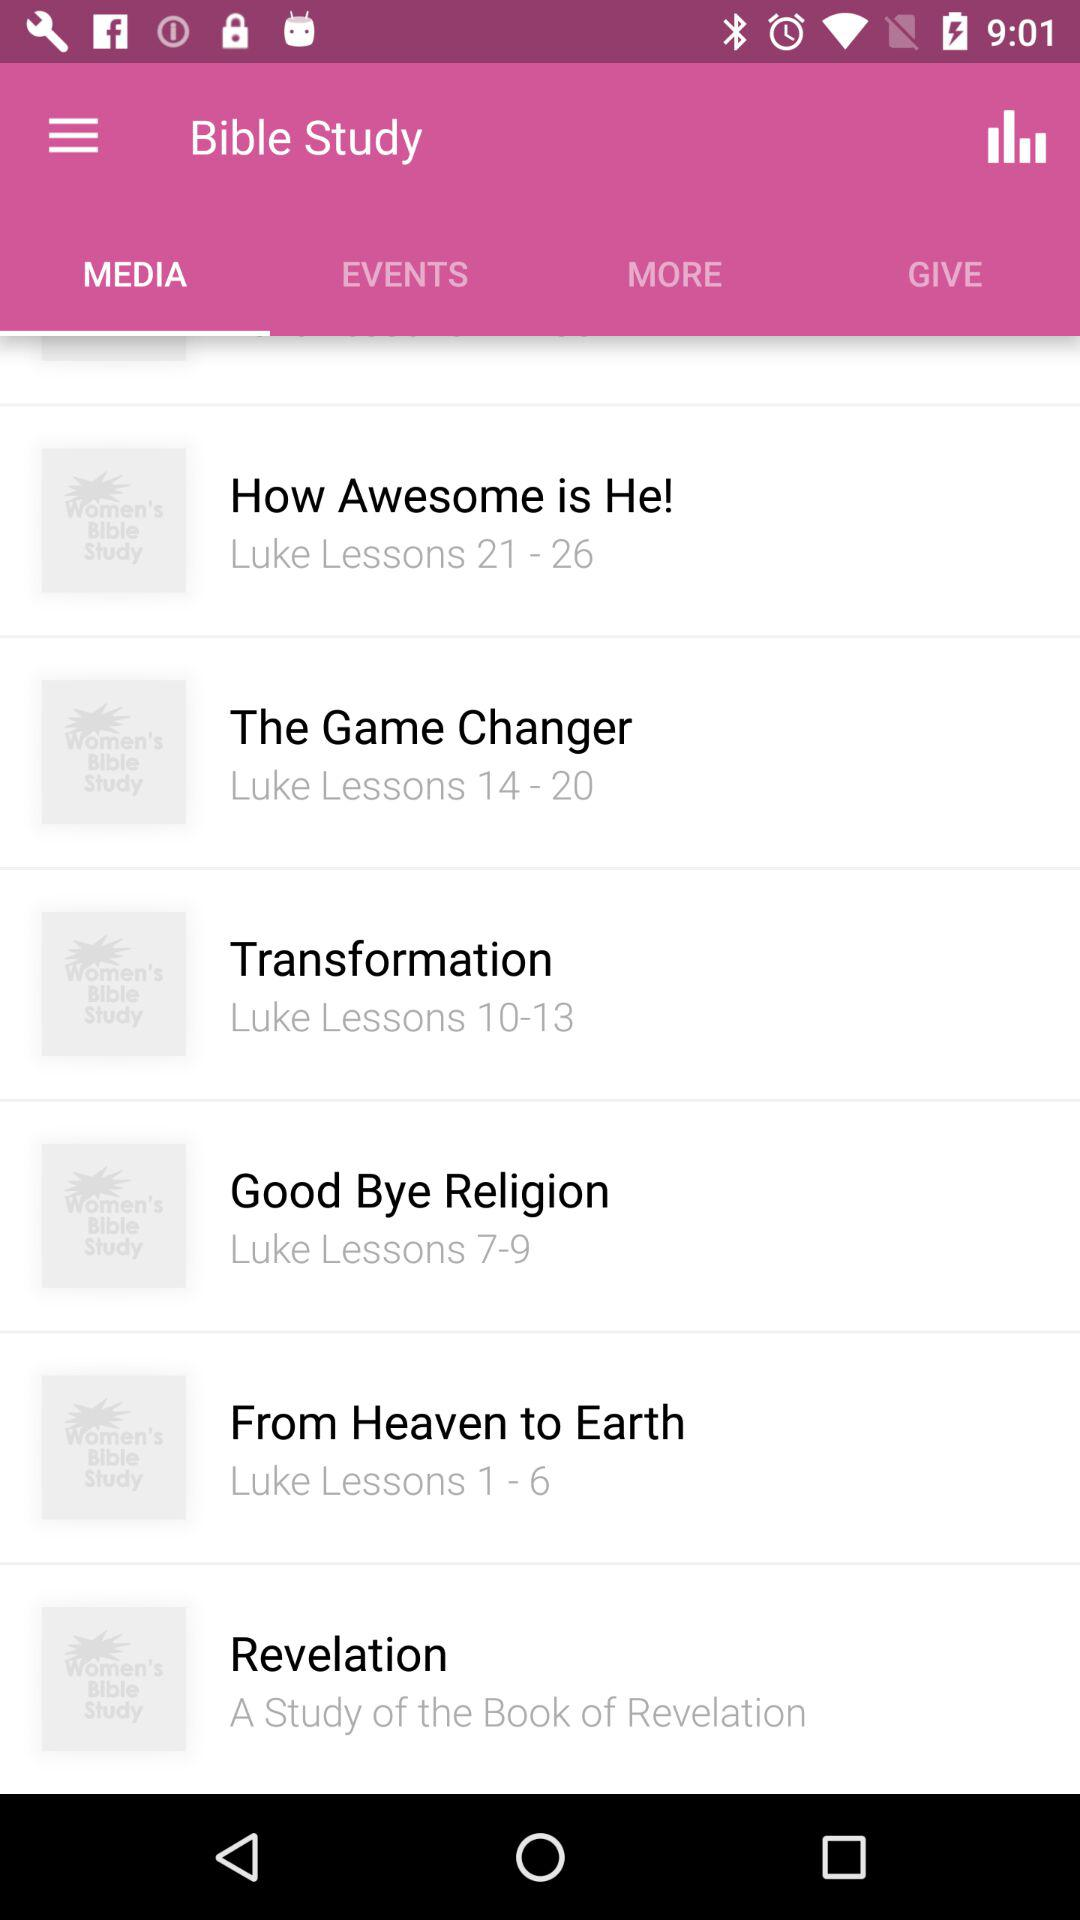How many Bible Studies are there in total?
Answer the question using a single word or phrase. 6 